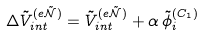<formula> <loc_0><loc_0><loc_500><loc_500>\Delta \tilde { V } _ { i n t } ^ { ( e \tilde { \mathcal { N } } ) } & = \tilde { V } _ { i n t } ^ { ( e \tilde { \mathcal { N } } ) } + \alpha \, \tilde { \phi } _ { i } ^ { ( C _ { 1 } ) }</formula> 